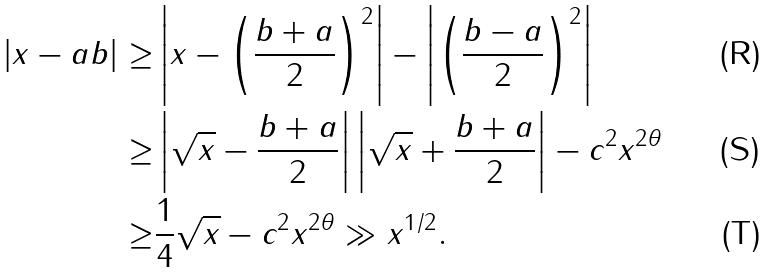Convert formula to latex. <formula><loc_0><loc_0><loc_500><loc_500>| x - a b | \geq & \left | x - \left ( \frac { b + a } { 2 } \right ) ^ { 2 } \right | - \left | \left ( \frac { b - a } { 2 } \right ) ^ { 2 } \right | \\ \geq & \left | \sqrt { x } - \frac { b + a } { 2 } \right | \left | \sqrt { x } + \frac { b + a } { 2 } \right | - c ^ { 2 } x ^ { 2 \theta } \\ \geq & \frac { 1 } { 4 } \sqrt { x } - c ^ { 2 } x ^ { 2 \theta } \gg x ^ { 1 / 2 } .</formula> 